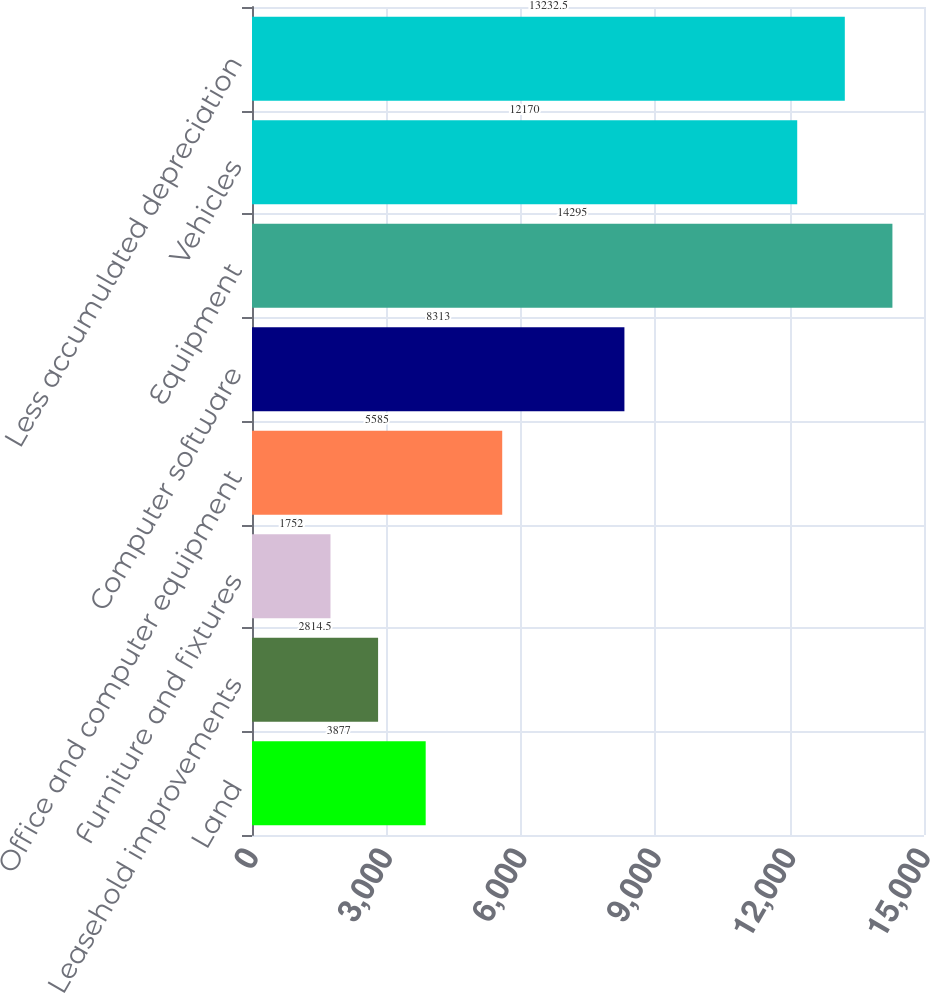<chart> <loc_0><loc_0><loc_500><loc_500><bar_chart><fcel>Land<fcel>Leasehold improvements<fcel>Furniture and fixtures<fcel>Office and computer equipment<fcel>Computer software<fcel>Equipment<fcel>Vehicles<fcel>Less accumulated depreciation<nl><fcel>3877<fcel>2814.5<fcel>1752<fcel>5585<fcel>8313<fcel>14295<fcel>12170<fcel>13232.5<nl></chart> 